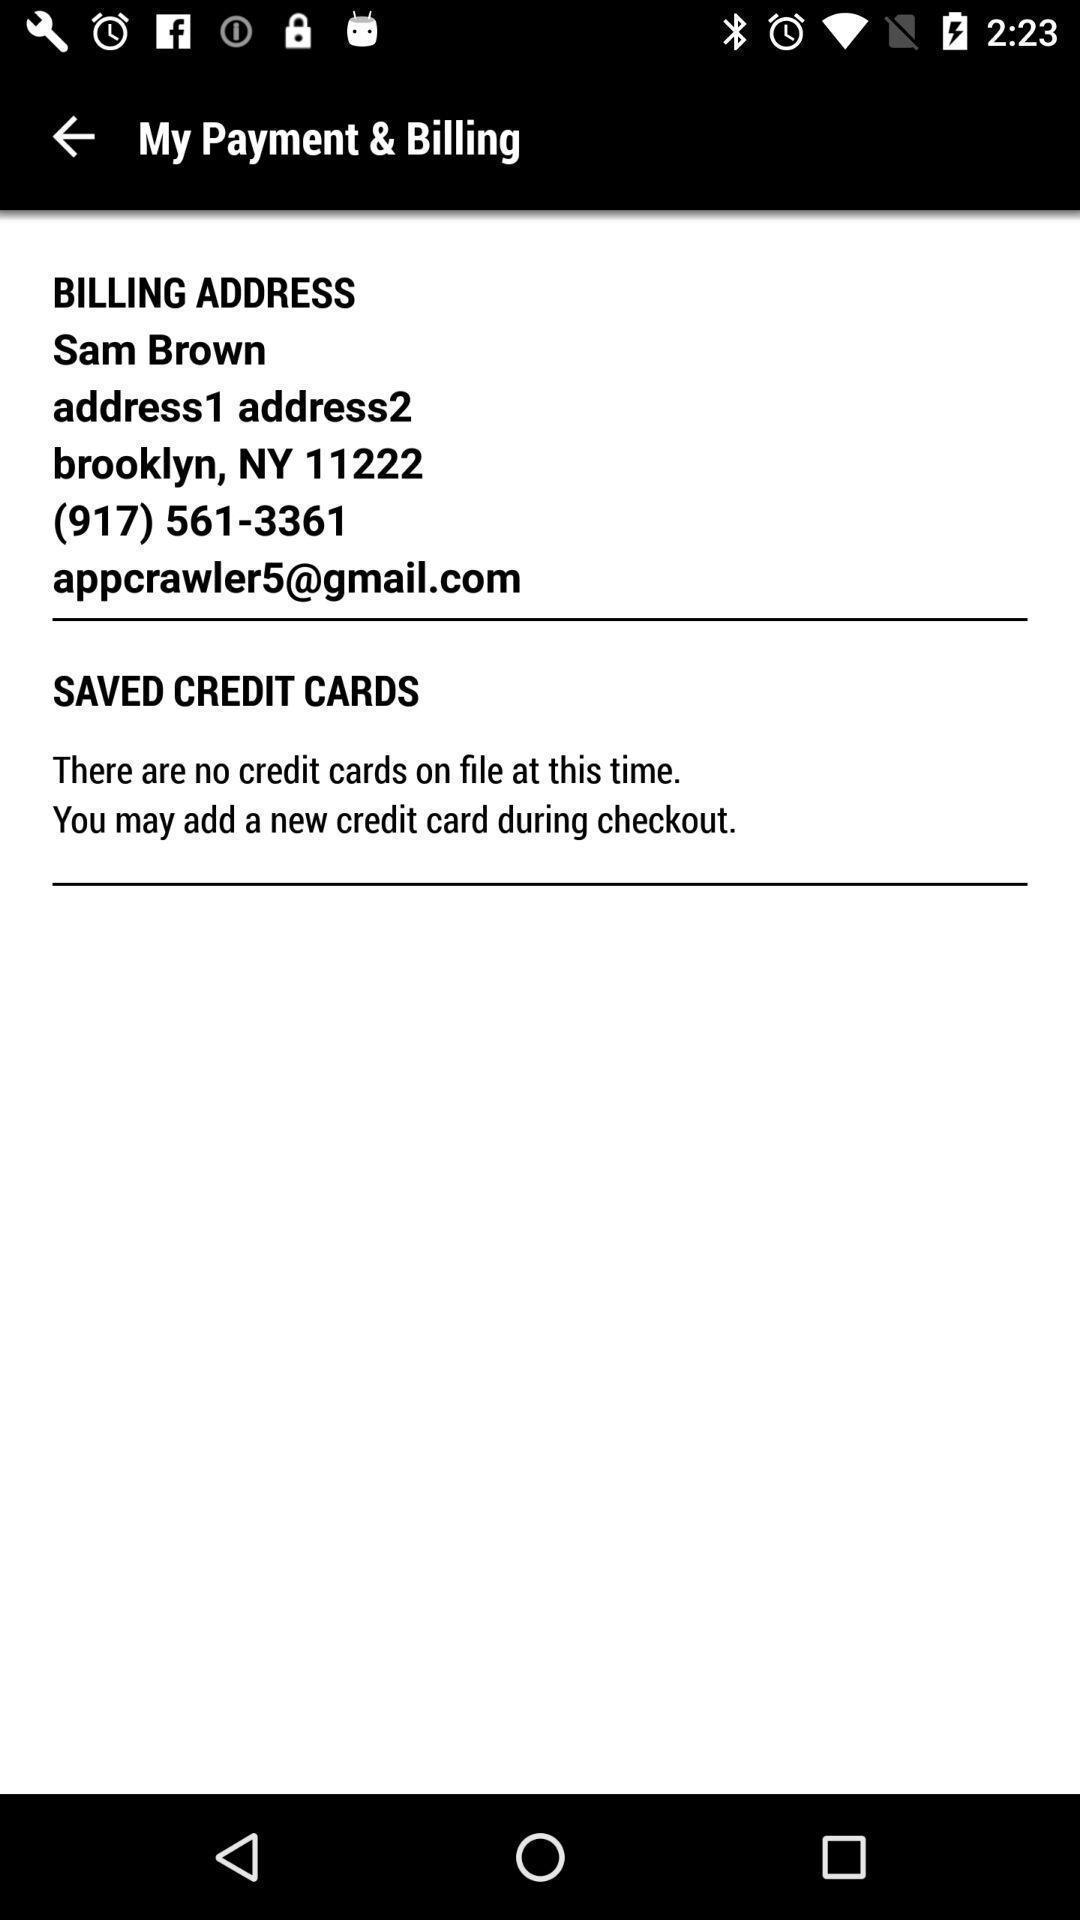Provide a detailed account of this screenshot. Page displaying the profile details in payment app. 